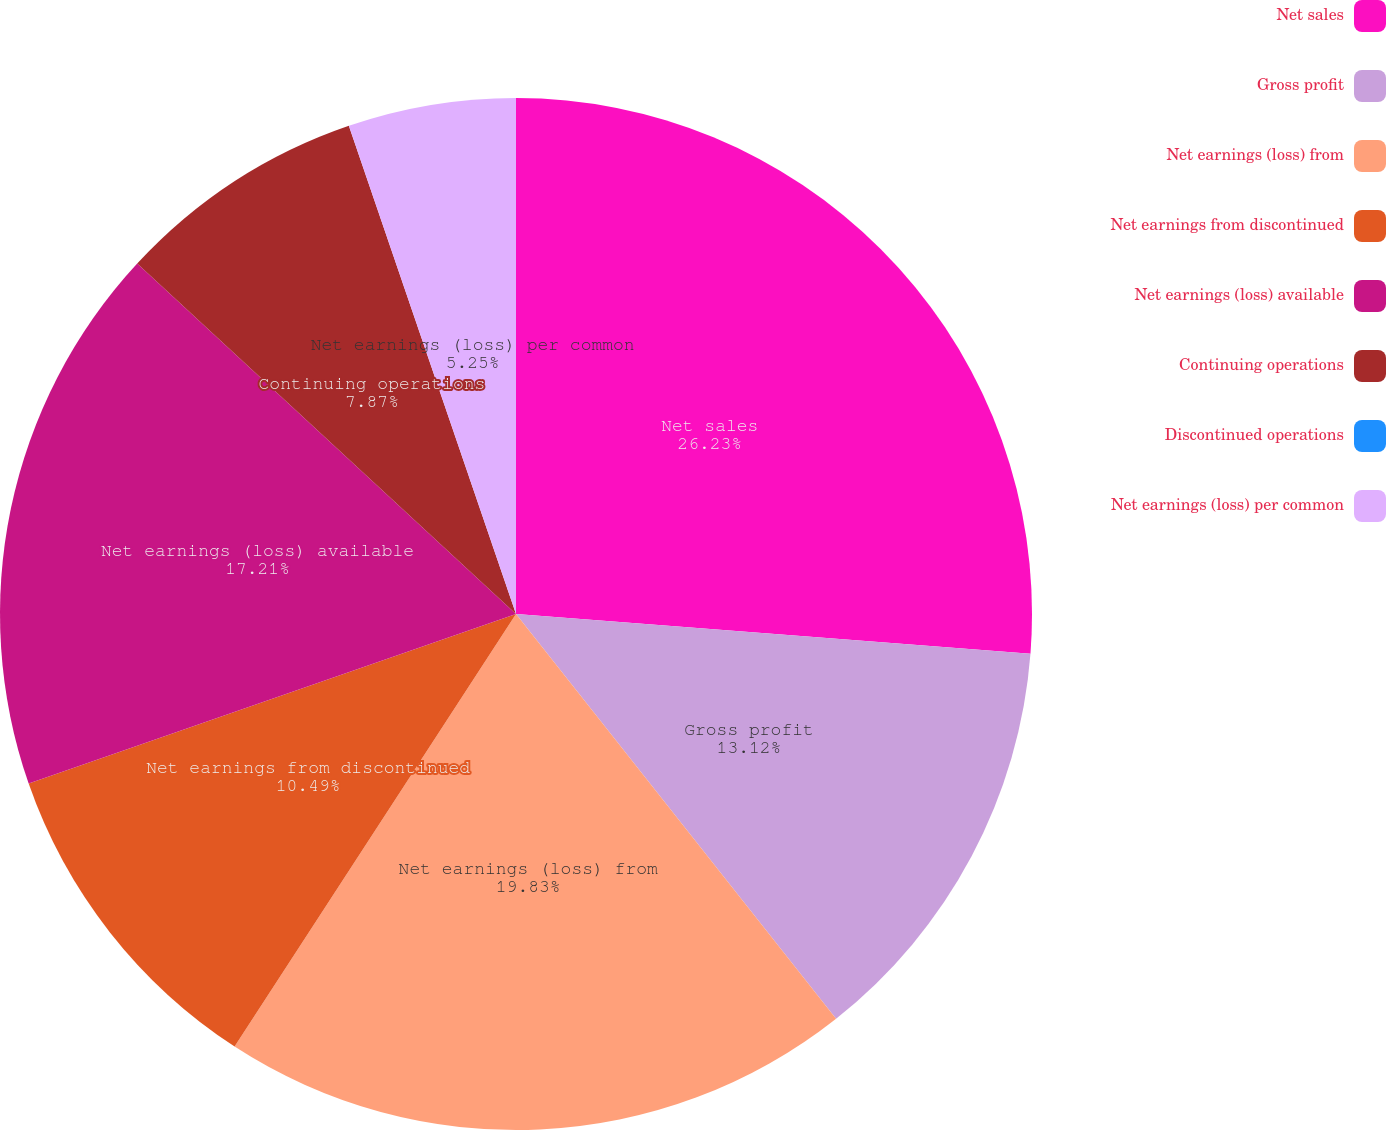Convert chart. <chart><loc_0><loc_0><loc_500><loc_500><pie_chart><fcel>Net sales<fcel>Gross profit<fcel>Net earnings (loss) from<fcel>Net earnings from discontinued<fcel>Net earnings (loss) available<fcel>Continuing operations<fcel>Discontinued operations<fcel>Net earnings (loss) per common<nl><fcel>26.23%<fcel>13.12%<fcel>19.83%<fcel>10.49%<fcel>17.21%<fcel>7.87%<fcel>0.0%<fcel>5.25%<nl></chart> 